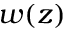<formula> <loc_0><loc_0><loc_500><loc_500>w ( z )</formula> 